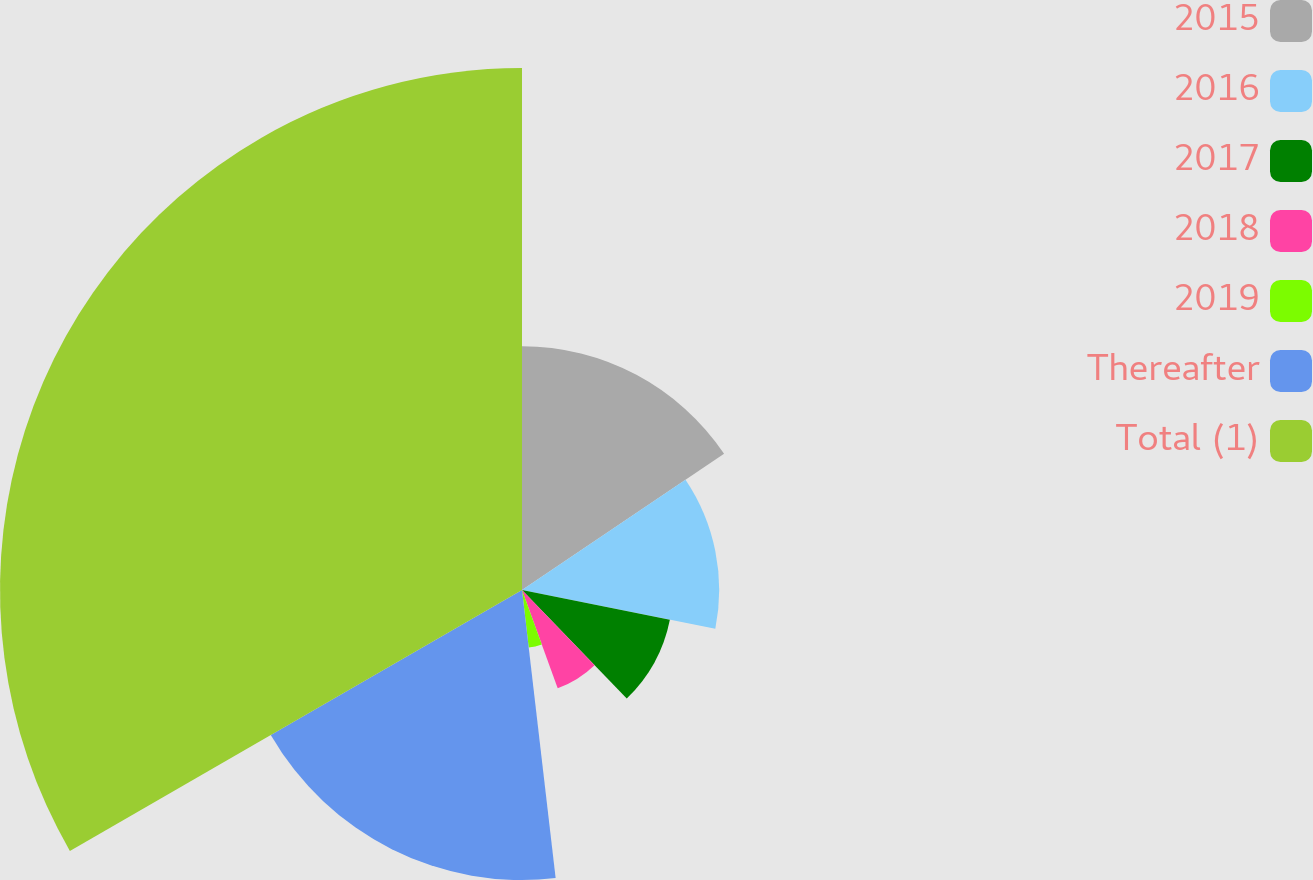Convert chart to OTSL. <chart><loc_0><loc_0><loc_500><loc_500><pie_chart><fcel>2015<fcel>2016<fcel>2017<fcel>2018<fcel>2019<fcel>Thereafter<fcel>Total (1)<nl><fcel>15.56%<fcel>12.59%<fcel>9.63%<fcel>6.67%<fcel>3.7%<fcel>18.52%<fcel>33.33%<nl></chart> 